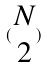Convert formula to latex. <formula><loc_0><loc_0><loc_500><loc_500>( \begin{matrix} N \\ 2 \end{matrix} )</formula> 